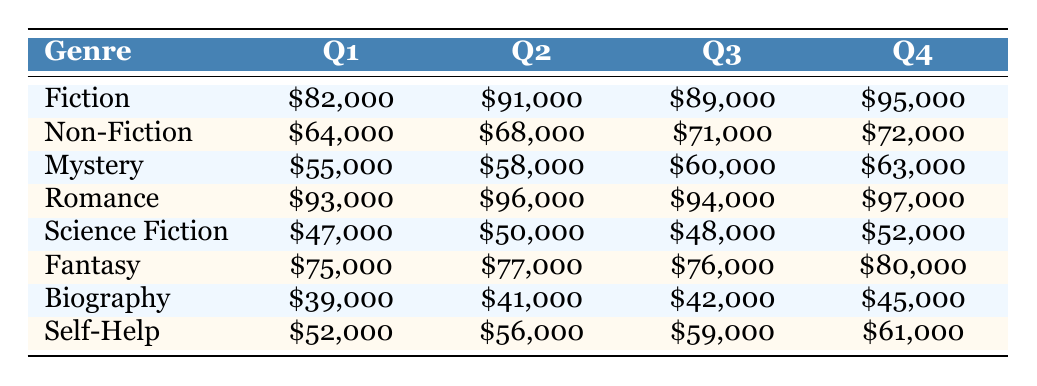What is the total revenue for Fiction across all quarters? To calculate the total revenue for Fiction, we sum the revenues from each quarter: 82000 (Q1) + 91000 (Q2) + 89000 (Q3) + 95000 (Q4) = 357000.
Answer: 357000 Which genre had the highest revenue in Q4? In Q4, the revenue for different genres is: Fiction at 95000, Non-Fiction at 72000, Mystery at 63000, Romance at 97000, Science Fiction at 52000, Fantasy at 80000, Biography at 45000, and Self-Help at 61000. The highest among these is Romance at 97000.
Answer: Romance What is the average revenue for the Fantasy genre across all quarters? The revenue for Fantasy across the quarters is 75000 (Q1), 77000 (Q2), 76000 (Q3), and 80000 (Q4). To compute the average, we sum these values: 75000 + 77000 + 76000 + 80000 = 308000, and then divide by 4, resulting in 308000 / 4 = 77000.
Answer: 77000 Did Science Fiction generate more revenue in Q3 than Biography in Q1? The revenue for Science Fiction in Q3 is 48000, and for Biography in Q1, it is 39000. Comparing these, 48000 (Science Fiction) is greater than 39000 (Biography).
Answer: Yes What is the total revenue for Non-Fiction in Q1 and Q2 combined? For Non-Fiction, the revenue in Q1 is 64000 and in Q2 is 68000. Adding these values together gives: 64000 + 68000 = 132000.
Answer: 132000 